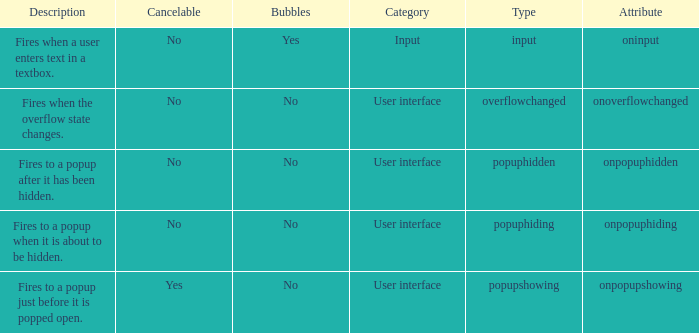What's the type with description being fires when the overflow state changes. Overflowchanged. 